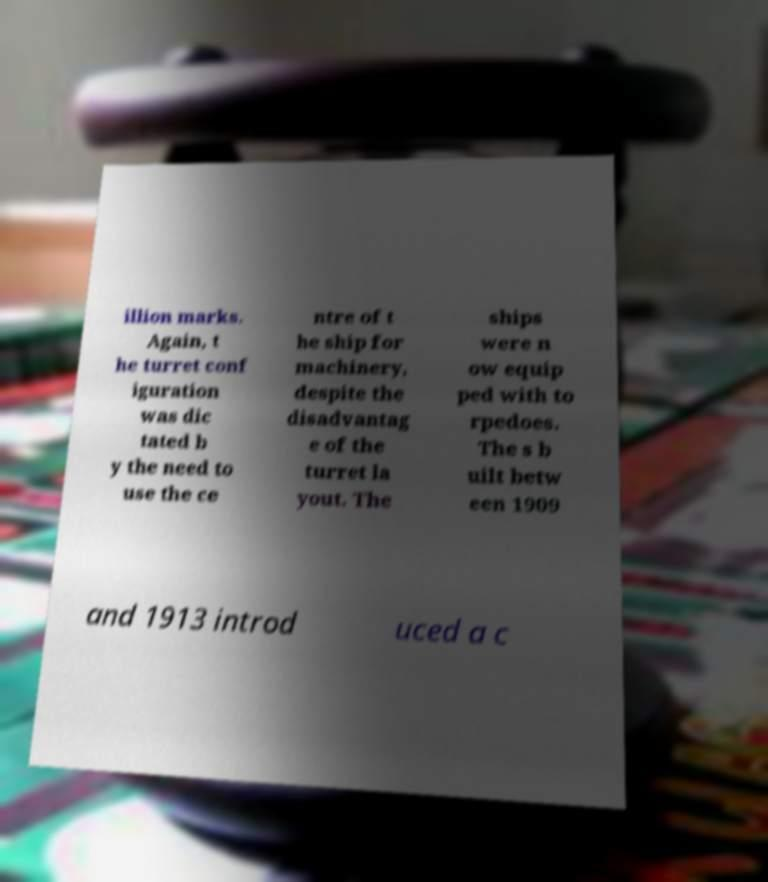Please read and relay the text visible in this image. What does it say? illion marks. Again, t he turret conf iguration was dic tated b y the need to use the ce ntre of t he ship for machinery, despite the disadvantag e of the turret la yout. The ships were n ow equip ped with to rpedoes. The s b uilt betw een 1909 and 1913 introd uced a c 